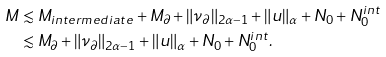Convert formula to latex. <formula><loc_0><loc_0><loc_500><loc_500>M & \lesssim M _ { i n t e r m e d i a t e } + M _ { \partial } + \| \nu _ { \partial } \| _ { 2 \alpha - 1 } + \| u \| _ { \alpha } + N _ { 0 } + N _ { 0 } ^ { i n t } \\ & \lesssim M _ { \partial } + \| \nu _ { \partial } \| _ { 2 \alpha - 1 } + \| u \| _ { \alpha } + N _ { 0 } + N _ { 0 } ^ { i n t } .</formula> 